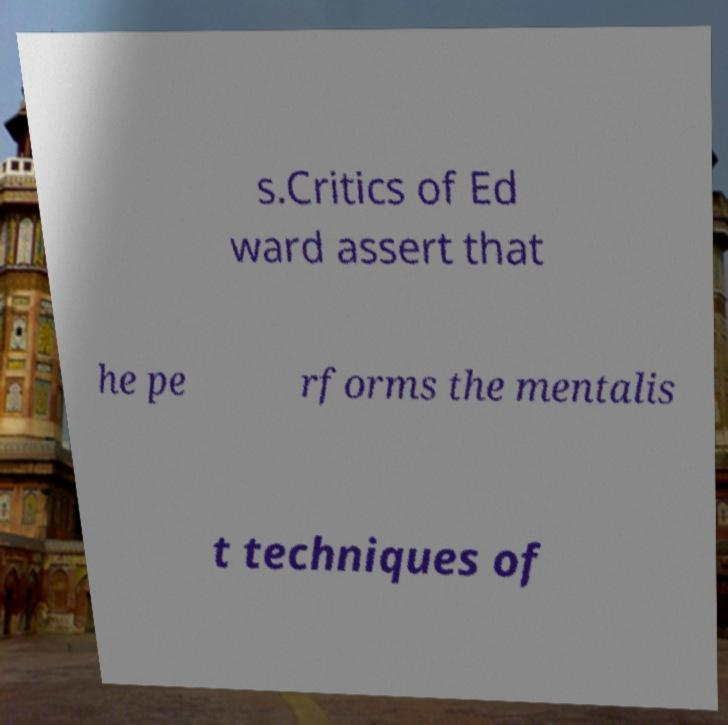Can you accurately transcribe the text from the provided image for me? s.Critics of Ed ward assert that he pe rforms the mentalis t techniques of 